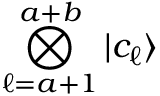<formula> <loc_0><loc_0><loc_500><loc_500>\bigotimes _ { \ell = a + 1 } ^ { a + b } \ m a t h i n n e r { | { c _ { \ell } } \rangle }</formula> 